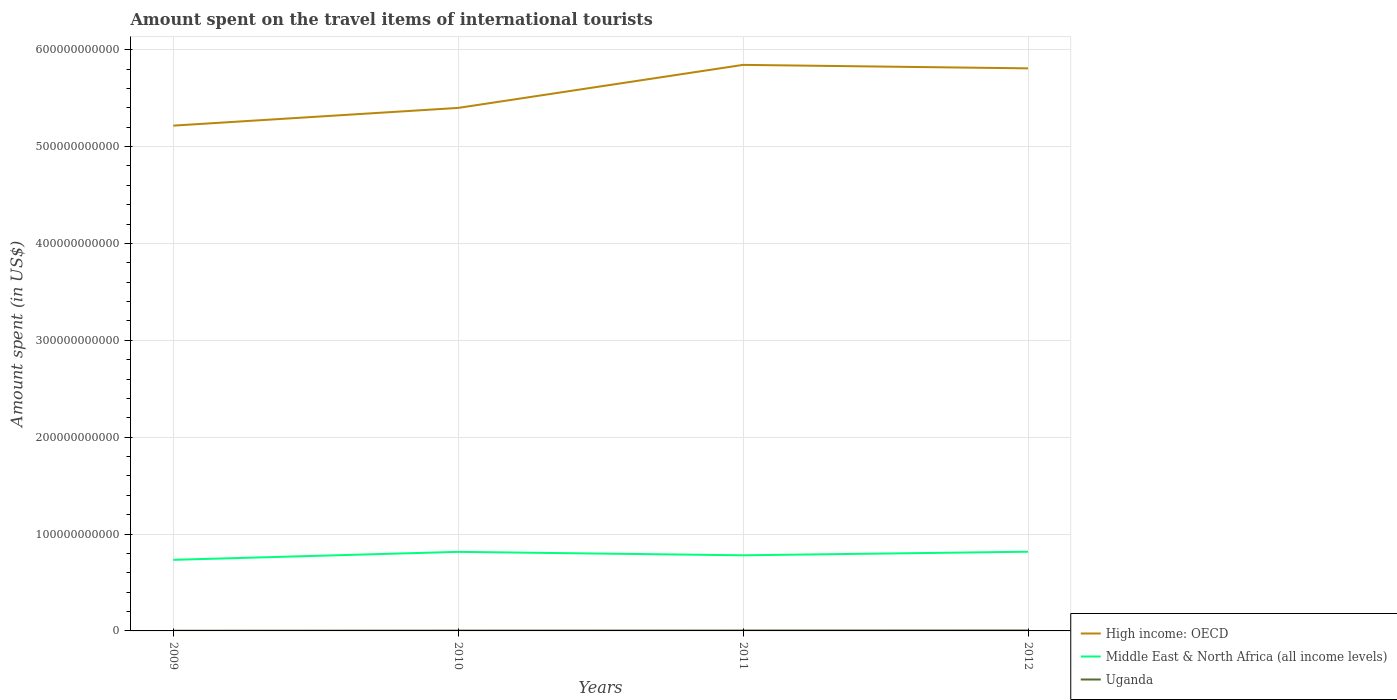How many different coloured lines are there?
Keep it short and to the point. 3. Does the line corresponding to High income: OECD intersect with the line corresponding to Middle East & North Africa (all income levels)?
Your answer should be very brief. No. Across all years, what is the maximum amount spent on the travel items of international tourists in High income: OECD?
Your answer should be very brief. 5.22e+11. What is the total amount spent on the travel items of international tourists in Middle East & North Africa (all income levels) in the graph?
Offer a terse response. -4.70e+09. What is the difference between the highest and the second highest amount spent on the travel items of international tourists in Middle East & North Africa (all income levels)?
Provide a succinct answer. 8.37e+09. What is the difference between the highest and the lowest amount spent on the travel items of international tourists in Middle East & North Africa (all income levels)?
Make the answer very short. 2. Is the amount spent on the travel items of international tourists in Middle East & North Africa (all income levels) strictly greater than the amount spent on the travel items of international tourists in Uganda over the years?
Offer a very short reply. No. How many lines are there?
Your response must be concise. 3. How many years are there in the graph?
Your answer should be very brief. 4. What is the difference between two consecutive major ticks on the Y-axis?
Provide a succinct answer. 1.00e+11. What is the title of the graph?
Your answer should be compact. Amount spent on the travel items of international tourists. What is the label or title of the Y-axis?
Make the answer very short. Amount spent (in US$). What is the Amount spent (in US$) of High income: OECD in 2009?
Offer a very short reply. 5.22e+11. What is the Amount spent (in US$) of Middle East & North Africa (all income levels) in 2009?
Offer a terse response. 7.34e+1. What is the Amount spent (in US$) in Uganda in 2009?
Ensure brevity in your answer.  1.92e+08. What is the Amount spent (in US$) of High income: OECD in 2010?
Your response must be concise. 5.40e+11. What is the Amount spent (in US$) of Middle East & North Africa (all income levels) in 2010?
Your answer should be very brief. 8.16e+1. What is the Amount spent (in US$) in Uganda in 2010?
Keep it short and to the point. 3.20e+08. What is the Amount spent (in US$) of High income: OECD in 2011?
Your answer should be compact. 5.84e+11. What is the Amount spent (in US$) in Middle East & North Africa (all income levels) in 2011?
Give a very brief answer. 7.81e+1. What is the Amount spent (in US$) of Uganda in 2011?
Ensure brevity in your answer.  4.05e+08. What is the Amount spent (in US$) in High income: OECD in 2012?
Offer a very short reply. 5.81e+11. What is the Amount spent (in US$) of Middle East & North Africa (all income levels) in 2012?
Provide a short and direct response. 8.17e+1. What is the Amount spent (in US$) of Uganda in 2012?
Ensure brevity in your answer.  4.84e+08. Across all years, what is the maximum Amount spent (in US$) of High income: OECD?
Keep it short and to the point. 5.84e+11. Across all years, what is the maximum Amount spent (in US$) of Middle East & North Africa (all income levels)?
Offer a very short reply. 8.17e+1. Across all years, what is the maximum Amount spent (in US$) in Uganda?
Keep it short and to the point. 4.84e+08. Across all years, what is the minimum Amount spent (in US$) of High income: OECD?
Your answer should be very brief. 5.22e+11. Across all years, what is the minimum Amount spent (in US$) in Middle East & North Africa (all income levels)?
Your response must be concise. 7.34e+1. Across all years, what is the minimum Amount spent (in US$) of Uganda?
Offer a terse response. 1.92e+08. What is the total Amount spent (in US$) in High income: OECD in the graph?
Offer a very short reply. 2.23e+12. What is the total Amount spent (in US$) of Middle East & North Africa (all income levels) in the graph?
Ensure brevity in your answer.  3.15e+11. What is the total Amount spent (in US$) of Uganda in the graph?
Offer a terse response. 1.40e+09. What is the difference between the Amount spent (in US$) in High income: OECD in 2009 and that in 2010?
Keep it short and to the point. -1.83e+1. What is the difference between the Amount spent (in US$) of Middle East & North Africa (all income levels) in 2009 and that in 2010?
Ensure brevity in your answer.  -8.25e+09. What is the difference between the Amount spent (in US$) of Uganda in 2009 and that in 2010?
Your answer should be compact. -1.28e+08. What is the difference between the Amount spent (in US$) of High income: OECD in 2009 and that in 2011?
Your response must be concise. -6.27e+1. What is the difference between the Amount spent (in US$) of Middle East & North Africa (all income levels) in 2009 and that in 2011?
Offer a terse response. -4.70e+09. What is the difference between the Amount spent (in US$) in Uganda in 2009 and that in 2011?
Keep it short and to the point. -2.13e+08. What is the difference between the Amount spent (in US$) of High income: OECD in 2009 and that in 2012?
Give a very brief answer. -5.91e+1. What is the difference between the Amount spent (in US$) of Middle East & North Africa (all income levels) in 2009 and that in 2012?
Provide a succinct answer. -8.37e+09. What is the difference between the Amount spent (in US$) in Uganda in 2009 and that in 2012?
Provide a short and direct response. -2.92e+08. What is the difference between the Amount spent (in US$) in High income: OECD in 2010 and that in 2011?
Provide a succinct answer. -4.44e+1. What is the difference between the Amount spent (in US$) in Middle East & North Africa (all income levels) in 2010 and that in 2011?
Provide a short and direct response. 3.55e+09. What is the difference between the Amount spent (in US$) in Uganda in 2010 and that in 2011?
Provide a short and direct response. -8.50e+07. What is the difference between the Amount spent (in US$) in High income: OECD in 2010 and that in 2012?
Keep it short and to the point. -4.08e+1. What is the difference between the Amount spent (in US$) of Middle East & North Africa (all income levels) in 2010 and that in 2012?
Your answer should be compact. -1.25e+08. What is the difference between the Amount spent (in US$) of Uganda in 2010 and that in 2012?
Give a very brief answer. -1.64e+08. What is the difference between the Amount spent (in US$) of High income: OECD in 2011 and that in 2012?
Give a very brief answer. 3.60e+09. What is the difference between the Amount spent (in US$) of Middle East & North Africa (all income levels) in 2011 and that in 2012?
Give a very brief answer. -3.68e+09. What is the difference between the Amount spent (in US$) of Uganda in 2011 and that in 2012?
Provide a short and direct response. -7.90e+07. What is the difference between the Amount spent (in US$) of High income: OECD in 2009 and the Amount spent (in US$) of Middle East & North Africa (all income levels) in 2010?
Your answer should be very brief. 4.40e+11. What is the difference between the Amount spent (in US$) in High income: OECD in 2009 and the Amount spent (in US$) in Uganda in 2010?
Your answer should be very brief. 5.21e+11. What is the difference between the Amount spent (in US$) in Middle East & North Africa (all income levels) in 2009 and the Amount spent (in US$) in Uganda in 2010?
Provide a short and direct response. 7.31e+1. What is the difference between the Amount spent (in US$) of High income: OECD in 2009 and the Amount spent (in US$) of Middle East & North Africa (all income levels) in 2011?
Make the answer very short. 4.44e+11. What is the difference between the Amount spent (in US$) of High income: OECD in 2009 and the Amount spent (in US$) of Uganda in 2011?
Your answer should be very brief. 5.21e+11. What is the difference between the Amount spent (in US$) of Middle East & North Africa (all income levels) in 2009 and the Amount spent (in US$) of Uganda in 2011?
Keep it short and to the point. 7.30e+1. What is the difference between the Amount spent (in US$) of High income: OECD in 2009 and the Amount spent (in US$) of Middle East & North Africa (all income levels) in 2012?
Offer a terse response. 4.40e+11. What is the difference between the Amount spent (in US$) in High income: OECD in 2009 and the Amount spent (in US$) in Uganda in 2012?
Offer a terse response. 5.21e+11. What is the difference between the Amount spent (in US$) of Middle East & North Africa (all income levels) in 2009 and the Amount spent (in US$) of Uganda in 2012?
Give a very brief answer. 7.29e+1. What is the difference between the Amount spent (in US$) in High income: OECD in 2010 and the Amount spent (in US$) in Middle East & North Africa (all income levels) in 2011?
Provide a short and direct response. 4.62e+11. What is the difference between the Amount spent (in US$) in High income: OECD in 2010 and the Amount spent (in US$) in Uganda in 2011?
Your answer should be compact. 5.40e+11. What is the difference between the Amount spent (in US$) of Middle East & North Africa (all income levels) in 2010 and the Amount spent (in US$) of Uganda in 2011?
Offer a very short reply. 8.12e+1. What is the difference between the Amount spent (in US$) in High income: OECD in 2010 and the Amount spent (in US$) in Middle East & North Africa (all income levels) in 2012?
Give a very brief answer. 4.58e+11. What is the difference between the Amount spent (in US$) in High income: OECD in 2010 and the Amount spent (in US$) in Uganda in 2012?
Your answer should be very brief. 5.39e+11. What is the difference between the Amount spent (in US$) in Middle East & North Africa (all income levels) in 2010 and the Amount spent (in US$) in Uganda in 2012?
Offer a very short reply. 8.11e+1. What is the difference between the Amount spent (in US$) in High income: OECD in 2011 and the Amount spent (in US$) in Middle East & North Africa (all income levels) in 2012?
Keep it short and to the point. 5.03e+11. What is the difference between the Amount spent (in US$) in High income: OECD in 2011 and the Amount spent (in US$) in Uganda in 2012?
Make the answer very short. 5.84e+11. What is the difference between the Amount spent (in US$) of Middle East & North Africa (all income levels) in 2011 and the Amount spent (in US$) of Uganda in 2012?
Offer a very short reply. 7.76e+1. What is the average Amount spent (in US$) in High income: OECD per year?
Your answer should be compact. 5.57e+11. What is the average Amount spent (in US$) in Middle East & North Africa (all income levels) per year?
Make the answer very short. 7.87e+1. What is the average Amount spent (in US$) of Uganda per year?
Provide a succinct answer. 3.50e+08. In the year 2009, what is the difference between the Amount spent (in US$) in High income: OECD and Amount spent (in US$) in Middle East & North Africa (all income levels)?
Provide a succinct answer. 4.48e+11. In the year 2009, what is the difference between the Amount spent (in US$) in High income: OECD and Amount spent (in US$) in Uganda?
Your answer should be compact. 5.21e+11. In the year 2009, what is the difference between the Amount spent (in US$) of Middle East & North Africa (all income levels) and Amount spent (in US$) of Uganda?
Give a very brief answer. 7.32e+1. In the year 2010, what is the difference between the Amount spent (in US$) in High income: OECD and Amount spent (in US$) in Middle East & North Africa (all income levels)?
Your response must be concise. 4.58e+11. In the year 2010, what is the difference between the Amount spent (in US$) of High income: OECD and Amount spent (in US$) of Uganda?
Ensure brevity in your answer.  5.40e+11. In the year 2010, what is the difference between the Amount spent (in US$) of Middle East & North Africa (all income levels) and Amount spent (in US$) of Uganda?
Make the answer very short. 8.13e+1. In the year 2011, what is the difference between the Amount spent (in US$) in High income: OECD and Amount spent (in US$) in Middle East & North Africa (all income levels)?
Make the answer very short. 5.06e+11. In the year 2011, what is the difference between the Amount spent (in US$) of High income: OECD and Amount spent (in US$) of Uganda?
Your response must be concise. 5.84e+11. In the year 2011, what is the difference between the Amount spent (in US$) of Middle East & North Africa (all income levels) and Amount spent (in US$) of Uganda?
Your answer should be very brief. 7.77e+1. In the year 2012, what is the difference between the Amount spent (in US$) in High income: OECD and Amount spent (in US$) in Middle East & North Africa (all income levels)?
Offer a terse response. 4.99e+11. In the year 2012, what is the difference between the Amount spent (in US$) of High income: OECD and Amount spent (in US$) of Uganda?
Your response must be concise. 5.80e+11. In the year 2012, what is the difference between the Amount spent (in US$) of Middle East & North Africa (all income levels) and Amount spent (in US$) of Uganda?
Offer a very short reply. 8.13e+1. What is the ratio of the Amount spent (in US$) of High income: OECD in 2009 to that in 2010?
Provide a succinct answer. 0.97. What is the ratio of the Amount spent (in US$) of Middle East & North Africa (all income levels) in 2009 to that in 2010?
Provide a succinct answer. 0.9. What is the ratio of the Amount spent (in US$) in High income: OECD in 2009 to that in 2011?
Your answer should be very brief. 0.89. What is the ratio of the Amount spent (in US$) in Middle East & North Africa (all income levels) in 2009 to that in 2011?
Make the answer very short. 0.94. What is the ratio of the Amount spent (in US$) in Uganda in 2009 to that in 2011?
Ensure brevity in your answer.  0.47. What is the ratio of the Amount spent (in US$) in High income: OECD in 2009 to that in 2012?
Offer a very short reply. 0.9. What is the ratio of the Amount spent (in US$) in Middle East & North Africa (all income levels) in 2009 to that in 2012?
Your answer should be very brief. 0.9. What is the ratio of the Amount spent (in US$) of Uganda in 2009 to that in 2012?
Keep it short and to the point. 0.4. What is the ratio of the Amount spent (in US$) in High income: OECD in 2010 to that in 2011?
Provide a short and direct response. 0.92. What is the ratio of the Amount spent (in US$) of Middle East & North Africa (all income levels) in 2010 to that in 2011?
Offer a very short reply. 1.05. What is the ratio of the Amount spent (in US$) in Uganda in 2010 to that in 2011?
Give a very brief answer. 0.79. What is the ratio of the Amount spent (in US$) in High income: OECD in 2010 to that in 2012?
Provide a short and direct response. 0.93. What is the ratio of the Amount spent (in US$) of Middle East & North Africa (all income levels) in 2010 to that in 2012?
Offer a terse response. 1. What is the ratio of the Amount spent (in US$) in Uganda in 2010 to that in 2012?
Provide a succinct answer. 0.66. What is the ratio of the Amount spent (in US$) in Middle East & North Africa (all income levels) in 2011 to that in 2012?
Keep it short and to the point. 0.95. What is the ratio of the Amount spent (in US$) of Uganda in 2011 to that in 2012?
Give a very brief answer. 0.84. What is the difference between the highest and the second highest Amount spent (in US$) in High income: OECD?
Offer a terse response. 3.60e+09. What is the difference between the highest and the second highest Amount spent (in US$) in Middle East & North Africa (all income levels)?
Make the answer very short. 1.25e+08. What is the difference between the highest and the second highest Amount spent (in US$) in Uganda?
Your answer should be very brief. 7.90e+07. What is the difference between the highest and the lowest Amount spent (in US$) in High income: OECD?
Make the answer very short. 6.27e+1. What is the difference between the highest and the lowest Amount spent (in US$) of Middle East & North Africa (all income levels)?
Make the answer very short. 8.37e+09. What is the difference between the highest and the lowest Amount spent (in US$) of Uganda?
Offer a terse response. 2.92e+08. 